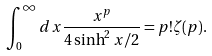Convert formula to latex. <formula><loc_0><loc_0><loc_500><loc_500>\int _ { 0 } ^ { \infty } d x \frac { x ^ { p } } { 4 \sinh ^ { 2 } x / 2 } = p ! \zeta ( p ) .</formula> 